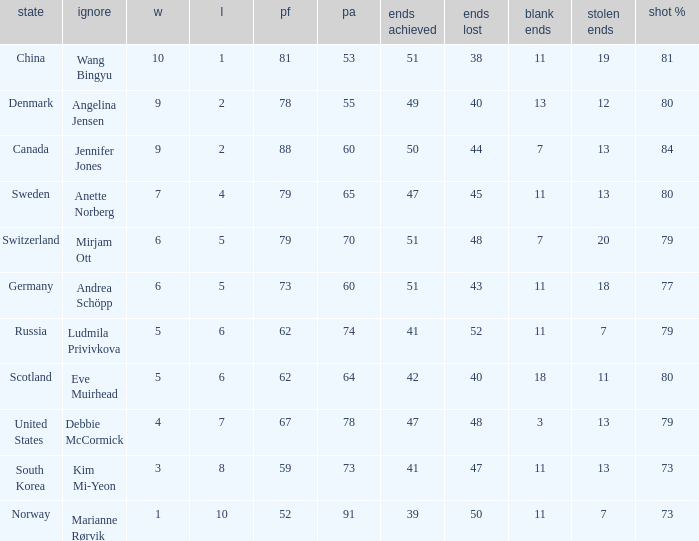When the country was Scotland, how many ends were won? 1.0. 